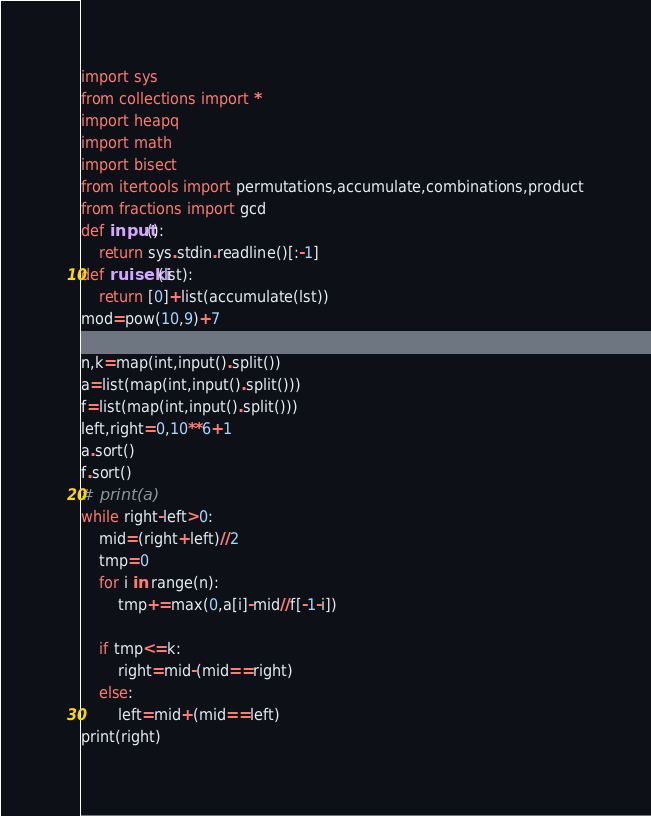<code> <loc_0><loc_0><loc_500><loc_500><_Python_>import sys
from collections import *
import heapq
import math
import bisect
from itertools import permutations,accumulate,combinations,product
from fractions import gcd
def input():
    return sys.stdin.readline()[:-1]
def ruiseki(lst):
    return [0]+list(accumulate(lst))
mod=pow(10,9)+7

n,k=map(int,input().split())
a=list(map(int,input().split()))
f=list(map(int,input().split()))
left,right=0,10**6+1
a.sort()
f.sort()
# print(a)
while right-left>0:
    mid=(right+left)//2
    tmp=0
    for i in range(n):
        tmp+=max(0,a[i]-mid//f[-1-i])
    
    if tmp<=k:
        right=mid-(mid==right)
    else:
        left=mid+(mid==left)
print(right)</code> 